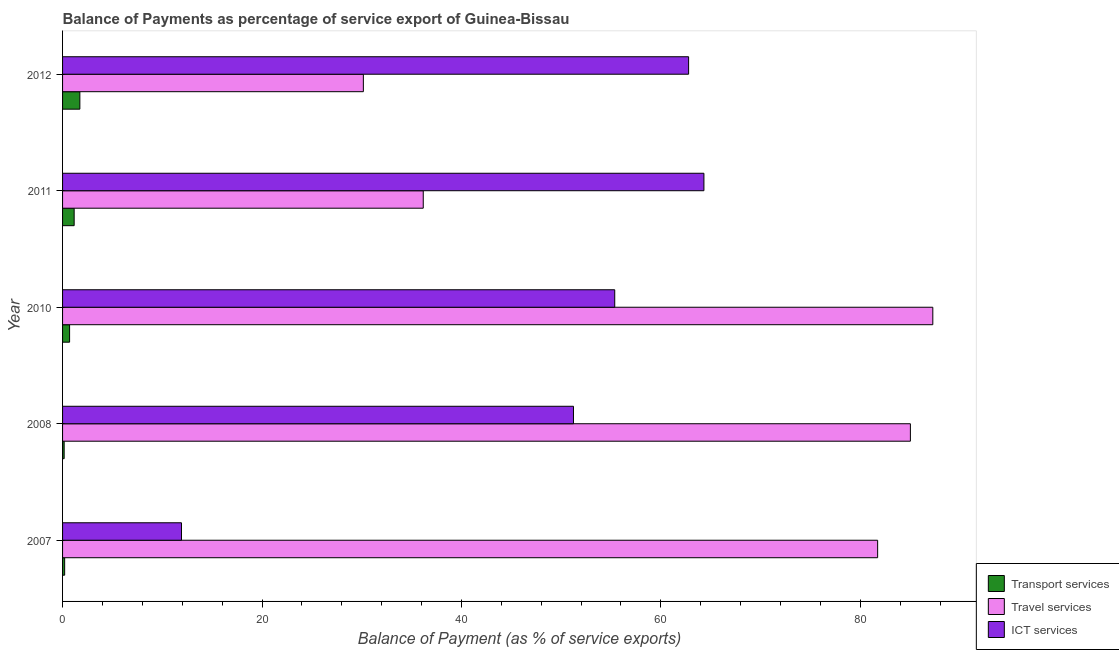How many different coloured bars are there?
Give a very brief answer. 3. How many groups of bars are there?
Offer a terse response. 5. Are the number of bars per tick equal to the number of legend labels?
Offer a very short reply. Yes. How many bars are there on the 5th tick from the bottom?
Your response must be concise. 3. What is the label of the 1st group of bars from the top?
Your answer should be compact. 2012. What is the balance of payment of travel services in 2010?
Your answer should be compact. 87.27. Across all years, what is the maximum balance of payment of ict services?
Provide a short and direct response. 64.32. Across all years, what is the minimum balance of payment of transport services?
Your response must be concise. 0.16. In which year was the balance of payment of travel services maximum?
Ensure brevity in your answer.  2010. What is the total balance of payment of ict services in the graph?
Provide a succinct answer. 245.65. What is the difference between the balance of payment of travel services in 2008 and that in 2012?
Make the answer very short. 54.86. What is the difference between the balance of payment of travel services in 2012 and the balance of payment of transport services in 2011?
Make the answer very short. 29. What is the average balance of payment of transport services per year?
Your answer should be very brief. 0.79. In the year 2012, what is the difference between the balance of payment of travel services and balance of payment of transport services?
Your answer should be compact. 28.43. What is the ratio of the balance of payment of travel services in 2007 to that in 2008?
Your response must be concise. 0.96. Is the balance of payment of travel services in 2007 less than that in 2012?
Make the answer very short. No. Is the difference between the balance of payment of transport services in 2007 and 2012 greater than the difference between the balance of payment of ict services in 2007 and 2012?
Offer a terse response. Yes. What is the difference between the highest and the second highest balance of payment of ict services?
Offer a terse response. 1.53. What is the difference between the highest and the lowest balance of payment of ict services?
Offer a very short reply. 52.39. What does the 2nd bar from the top in 2012 represents?
Ensure brevity in your answer.  Travel services. What does the 2nd bar from the bottom in 2012 represents?
Your answer should be very brief. Travel services. How many bars are there?
Keep it short and to the point. 15. Are all the bars in the graph horizontal?
Keep it short and to the point. Yes. How many years are there in the graph?
Provide a short and direct response. 5. Does the graph contain grids?
Provide a short and direct response. No. How many legend labels are there?
Your answer should be very brief. 3. What is the title of the graph?
Provide a short and direct response. Balance of Payments as percentage of service export of Guinea-Bissau. What is the label or title of the X-axis?
Provide a short and direct response. Balance of Payment (as % of service exports). What is the Balance of Payment (as % of service exports) in Transport services in 2007?
Your response must be concise. 0.21. What is the Balance of Payment (as % of service exports) of Travel services in 2007?
Keep it short and to the point. 81.74. What is the Balance of Payment (as % of service exports) in ICT services in 2007?
Provide a short and direct response. 11.93. What is the Balance of Payment (as % of service exports) of Transport services in 2008?
Provide a short and direct response. 0.16. What is the Balance of Payment (as % of service exports) in Travel services in 2008?
Make the answer very short. 85.03. What is the Balance of Payment (as % of service exports) in ICT services in 2008?
Keep it short and to the point. 51.24. What is the Balance of Payment (as % of service exports) in Transport services in 2010?
Keep it short and to the point. 0.7. What is the Balance of Payment (as % of service exports) of Travel services in 2010?
Offer a terse response. 87.27. What is the Balance of Payment (as % of service exports) of ICT services in 2010?
Your answer should be compact. 55.38. What is the Balance of Payment (as % of service exports) in Transport services in 2011?
Keep it short and to the point. 1.16. What is the Balance of Payment (as % of service exports) in Travel services in 2011?
Your response must be concise. 36.17. What is the Balance of Payment (as % of service exports) of ICT services in 2011?
Your response must be concise. 64.32. What is the Balance of Payment (as % of service exports) of Transport services in 2012?
Offer a terse response. 1.73. What is the Balance of Payment (as % of service exports) in Travel services in 2012?
Offer a terse response. 30.17. What is the Balance of Payment (as % of service exports) of ICT services in 2012?
Provide a short and direct response. 62.79. Across all years, what is the maximum Balance of Payment (as % of service exports) in Transport services?
Your response must be concise. 1.73. Across all years, what is the maximum Balance of Payment (as % of service exports) of Travel services?
Offer a terse response. 87.27. Across all years, what is the maximum Balance of Payment (as % of service exports) in ICT services?
Keep it short and to the point. 64.32. Across all years, what is the minimum Balance of Payment (as % of service exports) in Transport services?
Your answer should be compact. 0.16. Across all years, what is the minimum Balance of Payment (as % of service exports) in Travel services?
Offer a terse response. 30.17. Across all years, what is the minimum Balance of Payment (as % of service exports) of ICT services?
Keep it short and to the point. 11.93. What is the total Balance of Payment (as % of service exports) in Transport services in the graph?
Make the answer very short. 3.97. What is the total Balance of Payment (as % of service exports) of Travel services in the graph?
Your answer should be compact. 320.38. What is the total Balance of Payment (as % of service exports) in ICT services in the graph?
Offer a very short reply. 245.65. What is the difference between the Balance of Payment (as % of service exports) of Transport services in 2007 and that in 2008?
Ensure brevity in your answer.  0.05. What is the difference between the Balance of Payment (as % of service exports) of Travel services in 2007 and that in 2008?
Provide a succinct answer. -3.28. What is the difference between the Balance of Payment (as % of service exports) of ICT services in 2007 and that in 2008?
Your answer should be compact. -39.31. What is the difference between the Balance of Payment (as % of service exports) in Transport services in 2007 and that in 2010?
Ensure brevity in your answer.  -0.5. What is the difference between the Balance of Payment (as % of service exports) in Travel services in 2007 and that in 2010?
Provide a short and direct response. -5.53. What is the difference between the Balance of Payment (as % of service exports) in ICT services in 2007 and that in 2010?
Give a very brief answer. -43.45. What is the difference between the Balance of Payment (as % of service exports) of Transport services in 2007 and that in 2011?
Provide a succinct answer. -0.95. What is the difference between the Balance of Payment (as % of service exports) of Travel services in 2007 and that in 2011?
Give a very brief answer. 45.57. What is the difference between the Balance of Payment (as % of service exports) in ICT services in 2007 and that in 2011?
Offer a terse response. -52.39. What is the difference between the Balance of Payment (as % of service exports) of Transport services in 2007 and that in 2012?
Your response must be concise. -1.52. What is the difference between the Balance of Payment (as % of service exports) of Travel services in 2007 and that in 2012?
Make the answer very short. 51.58. What is the difference between the Balance of Payment (as % of service exports) of ICT services in 2007 and that in 2012?
Make the answer very short. -50.86. What is the difference between the Balance of Payment (as % of service exports) in Transport services in 2008 and that in 2010?
Provide a short and direct response. -0.54. What is the difference between the Balance of Payment (as % of service exports) of Travel services in 2008 and that in 2010?
Your answer should be compact. -2.25. What is the difference between the Balance of Payment (as % of service exports) in ICT services in 2008 and that in 2010?
Your response must be concise. -4.14. What is the difference between the Balance of Payment (as % of service exports) of Transport services in 2008 and that in 2011?
Ensure brevity in your answer.  -1. What is the difference between the Balance of Payment (as % of service exports) in Travel services in 2008 and that in 2011?
Provide a short and direct response. 48.85. What is the difference between the Balance of Payment (as % of service exports) in ICT services in 2008 and that in 2011?
Make the answer very short. -13.08. What is the difference between the Balance of Payment (as % of service exports) in Transport services in 2008 and that in 2012?
Give a very brief answer. -1.57. What is the difference between the Balance of Payment (as % of service exports) in Travel services in 2008 and that in 2012?
Your answer should be very brief. 54.86. What is the difference between the Balance of Payment (as % of service exports) in ICT services in 2008 and that in 2012?
Make the answer very short. -11.55. What is the difference between the Balance of Payment (as % of service exports) in Transport services in 2010 and that in 2011?
Your answer should be compact. -0.46. What is the difference between the Balance of Payment (as % of service exports) of Travel services in 2010 and that in 2011?
Your answer should be compact. 51.1. What is the difference between the Balance of Payment (as % of service exports) of ICT services in 2010 and that in 2011?
Your answer should be compact. -8.94. What is the difference between the Balance of Payment (as % of service exports) in Transport services in 2010 and that in 2012?
Keep it short and to the point. -1.03. What is the difference between the Balance of Payment (as % of service exports) of Travel services in 2010 and that in 2012?
Your answer should be very brief. 57.11. What is the difference between the Balance of Payment (as % of service exports) in ICT services in 2010 and that in 2012?
Your response must be concise. -7.41. What is the difference between the Balance of Payment (as % of service exports) of Transport services in 2011 and that in 2012?
Ensure brevity in your answer.  -0.57. What is the difference between the Balance of Payment (as % of service exports) of Travel services in 2011 and that in 2012?
Make the answer very short. 6.01. What is the difference between the Balance of Payment (as % of service exports) of ICT services in 2011 and that in 2012?
Your response must be concise. 1.53. What is the difference between the Balance of Payment (as % of service exports) of Transport services in 2007 and the Balance of Payment (as % of service exports) of Travel services in 2008?
Offer a very short reply. -84.82. What is the difference between the Balance of Payment (as % of service exports) of Transport services in 2007 and the Balance of Payment (as % of service exports) of ICT services in 2008?
Offer a terse response. -51.03. What is the difference between the Balance of Payment (as % of service exports) in Travel services in 2007 and the Balance of Payment (as % of service exports) in ICT services in 2008?
Keep it short and to the point. 30.5. What is the difference between the Balance of Payment (as % of service exports) of Transport services in 2007 and the Balance of Payment (as % of service exports) of Travel services in 2010?
Offer a very short reply. -87.06. What is the difference between the Balance of Payment (as % of service exports) in Transport services in 2007 and the Balance of Payment (as % of service exports) in ICT services in 2010?
Your answer should be compact. -55.17. What is the difference between the Balance of Payment (as % of service exports) of Travel services in 2007 and the Balance of Payment (as % of service exports) of ICT services in 2010?
Keep it short and to the point. 26.37. What is the difference between the Balance of Payment (as % of service exports) of Transport services in 2007 and the Balance of Payment (as % of service exports) of Travel services in 2011?
Your response must be concise. -35.96. What is the difference between the Balance of Payment (as % of service exports) in Transport services in 2007 and the Balance of Payment (as % of service exports) in ICT services in 2011?
Provide a short and direct response. -64.11. What is the difference between the Balance of Payment (as % of service exports) in Travel services in 2007 and the Balance of Payment (as % of service exports) in ICT services in 2011?
Provide a short and direct response. 17.42. What is the difference between the Balance of Payment (as % of service exports) in Transport services in 2007 and the Balance of Payment (as % of service exports) in Travel services in 2012?
Keep it short and to the point. -29.96. What is the difference between the Balance of Payment (as % of service exports) of Transport services in 2007 and the Balance of Payment (as % of service exports) of ICT services in 2012?
Your answer should be very brief. -62.58. What is the difference between the Balance of Payment (as % of service exports) of Travel services in 2007 and the Balance of Payment (as % of service exports) of ICT services in 2012?
Make the answer very short. 18.96. What is the difference between the Balance of Payment (as % of service exports) of Transport services in 2008 and the Balance of Payment (as % of service exports) of Travel services in 2010?
Your answer should be compact. -87.11. What is the difference between the Balance of Payment (as % of service exports) of Transport services in 2008 and the Balance of Payment (as % of service exports) of ICT services in 2010?
Give a very brief answer. -55.22. What is the difference between the Balance of Payment (as % of service exports) in Travel services in 2008 and the Balance of Payment (as % of service exports) in ICT services in 2010?
Your answer should be very brief. 29.65. What is the difference between the Balance of Payment (as % of service exports) of Transport services in 2008 and the Balance of Payment (as % of service exports) of Travel services in 2011?
Give a very brief answer. -36.01. What is the difference between the Balance of Payment (as % of service exports) in Transport services in 2008 and the Balance of Payment (as % of service exports) in ICT services in 2011?
Keep it short and to the point. -64.16. What is the difference between the Balance of Payment (as % of service exports) of Travel services in 2008 and the Balance of Payment (as % of service exports) of ICT services in 2011?
Provide a short and direct response. 20.71. What is the difference between the Balance of Payment (as % of service exports) in Transport services in 2008 and the Balance of Payment (as % of service exports) in Travel services in 2012?
Provide a short and direct response. -30.01. What is the difference between the Balance of Payment (as % of service exports) of Transport services in 2008 and the Balance of Payment (as % of service exports) of ICT services in 2012?
Make the answer very short. -62.63. What is the difference between the Balance of Payment (as % of service exports) in Travel services in 2008 and the Balance of Payment (as % of service exports) in ICT services in 2012?
Make the answer very short. 22.24. What is the difference between the Balance of Payment (as % of service exports) of Transport services in 2010 and the Balance of Payment (as % of service exports) of Travel services in 2011?
Your answer should be compact. -35.47. What is the difference between the Balance of Payment (as % of service exports) of Transport services in 2010 and the Balance of Payment (as % of service exports) of ICT services in 2011?
Give a very brief answer. -63.62. What is the difference between the Balance of Payment (as % of service exports) in Travel services in 2010 and the Balance of Payment (as % of service exports) in ICT services in 2011?
Keep it short and to the point. 22.95. What is the difference between the Balance of Payment (as % of service exports) in Transport services in 2010 and the Balance of Payment (as % of service exports) in Travel services in 2012?
Ensure brevity in your answer.  -29.46. What is the difference between the Balance of Payment (as % of service exports) of Transport services in 2010 and the Balance of Payment (as % of service exports) of ICT services in 2012?
Make the answer very short. -62.08. What is the difference between the Balance of Payment (as % of service exports) of Travel services in 2010 and the Balance of Payment (as % of service exports) of ICT services in 2012?
Your response must be concise. 24.49. What is the difference between the Balance of Payment (as % of service exports) in Transport services in 2011 and the Balance of Payment (as % of service exports) in Travel services in 2012?
Your response must be concise. -29. What is the difference between the Balance of Payment (as % of service exports) in Transport services in 2011 and the Balance of Payment (as % of service exports) in ICT services in 2012?
Give a very brief answer. -61.62. What is the difference between the Balance of Payment (as % of service exports) in Travel services in 2011 and the Balance of Payment (as % of service exports) in ICT services in 2012?
Offer a terse response. -26.61. What is the average Balance of Payment (as % of service exports) in Transport services per year?
Provide a short and direct response. 0.79. What is the average Balance of Payment (as % of service exports) in Travel services per year?
Give a very brief answer. 64.08. What is the average Balance of Payment (as % of service exports) in ICT services per year?
Give a very brief answer. 49.13. In the year 2007, what is the difference between the Balance of Payment (as % of service exports) in Transport services and Balance of Payment (as % of service exports) in Travel services?
Give a very brief answer. -81.53. In the year 2007, what is the difference between the Balance of Payment (as % of service exports) of Transport services and Balance of Payment (as % of service exports) of ICT services?
Make the answer very short. -11.72. In the year 2007, what is the difference between the Balance of Payment (as % of service exports) of Travel services and Balance of Payment (as % of service exports) of ICT services?
Your answer should be compact. 69.82. In the year 2008, what is the difference between the Balance of Payment (as % of service exports) in Transport services and Balance of Payment (as % of service exports) in Travel services?
Offer a terse response. -84.87. In the year 2008, what is the difference between the Balance of Payment (as % of service exports) in Transport services and Balance of Payment (as % of service exports) in ICT services?
Keep it short and to the point. -51.08. In the year 2008, what is the difference between the Balance of Payment (as % of service exports) of Travel services and Balance of Payment (as % of service exports) of ICT services?
Provide a short and direct response. 33.79. In the year 2010, what is the difference between the Balance of Payment (as % of service exports) of Transport services and Balance of Payment (as % of service exports) of Travel services?
Keep it short and to the point. -86.57. In the year 2010, what is the difference between the Balance of Payment (as % of service exports) in Transport services and Balance of Payment (as % of service exports) in ICT services?
Keep it short and to the point. -54.67. In the year 2010, what is the difference between the Balance of Payment (as % of service exports) in Travel services and Balance of Payment (as % of service exports) in ICT services?
Provide a short and direct response. 31.9. In the year 2011, what is the difference between the Balance of Payment (as % of service exports) of Transport services and Balance of Payment (as % of service exports) of Travel services?
Offer a terse response. -35.01. In the year 2011, what is the difference between the Balance of Payment (as % of service exports) in Transport services and Balance of Payment (as % of service exports) in ICT services?
Make the answer very short. -63.16. In the year 2011, what is the difference between the Balance of Payment (as % of service exports) in Travel services and Balance of Payment (as % of service exports) in ICT services?
Provide a short and direct response. -28.15. In the year 2012, what is the difference between the Balance of Payment (as % of service exports) of Transport services and Balance of Payment (as % of service exports) of Travel services?
Your answer should be very brief. -28.43. In the year 2012, what is the difference between the Balance of Payment (as % of service exports) in Transport services and Balance of Payment (as % of service exports) in ICT services?
Give a very brief answer. -61.05. In the year 2012, what is the difference between the Balance of Payment (as % of service exports) in Travel services and Balance of Payment (as % of service exports) in ICT services?
Offer a terse response. -32.62. What is the ratio of the Balance of Payment (as % of service exports) of Transport services in 2007 to that in 2008?
Your answer should be compact. 1.31. What is the ratio of the Balance of Payment (as % of service exports) of Travel services in 2007 to that in 2008?
Offer a very short reply. 0.96. What is the ratio of the Balance of Payment (as % of service exports) in ICT services in 2007 to that in 2008?
Keep it short and to the point. 0.23. What is the ratio of the Balance of Payment (as % of service exports) in Transport services in 2007 to that in 2010?
Your answer should be compact. 0.3. What is the ratio of the Balance of Payment (as % of service exports) in Travel services in 2007 to that in 2010?
Provide a succinct answer. 0.94. What is the ratio of the Balance of Payment (as % of service exports) in ICT services in 2007 to that in 2010?
Your answer should be very brief. 0.22. What is the ratio of the Balance of Payment (as % of service exports) in Transport services in 2007 to that in 2011?
Give a very brief answer. 0.18. What is the ratio of the Balance of Payment (as % of service exports) in Travel services in 2007 to that in 2011?
Ensure brevity in your answer.  2.26. What is the ratio of the Balance of Payment (as % of service exports) in ICT services in 2007 to that in 2011?
Provide a short and direct response. 0.19. What is the ratio of the Balance of Payment (as % of service exports) in Transport services in 2007 to that in 2012?
Your answer should be compact. 0.12. What is the ratio of the Balance of Payment (as % of service exports) in Travel services in 2007 to that in 2012?
Your answer should be compact. 2.71. What is the ratio of the Balance of Payment (as % of service exports) in ICT services in 2007 to that in 2012?
Provide a short and direct response. 0.19. What is the ratio of the Balance of Payment (as % of service exports) in Transport services in 2008 to that in 2010?
Give a very brief answer. 0.23. What is the ratio of the Balance of Payment (as % of service exports) of Travel services in 2008 to that in 2010?
Make the answer very short. 0.97. What is the ratio of the Balance of Payment (as % of service exports) of ICT services in 2008 to that in 2010?
Give a very brief answer. 0.93. What is the ratio of the Balance of Payment (as % of service exports) of Transport services in 2008 to that in 2011?
Offer a very short reply. 0.14. What is the ratio of the Balance of Payment (as % of service exports) of Travel services in 2008 to that in 2011?
Give a very brief answer. 2.35. What is the ratio of the Balance of Payment (as % of service exports) in ICT services in 2008 to that in 2011?
Offer a terse response. 0.8. What is the ratio of the Balance of Payment (as % of service exports) in Transport services in 2008 to that in 2012?
Make the answer very short. 0.09. What is the ratio of the Balance of Payment (as % of service exports) in Travel services in 2008 to that in 2012?
Provide a succinct answer. 2.82. What is the ratio of the Balance of Payment (as % of service exports) of ICT services in 2008 to that in 2012?
Give a very brief answer. 0.82. What is the ratio of the Balance of Payment (as % of service exports) in Transport services in 2010 to that in 2011?
Offer a very short reply. 0.61. What is the ratio of the Balance of Payment (as % of service exports) of Travel services in 2010 to that in 2011?
Ensure brevity in your answer.  2.41. What is the ratio of the Balance of Payment (as % of service exports) in ICT services in 2010 to that in 2011?
Give a very brief answer. 0.86. What is the ratio of the Balance of Payment (as % of service exports) in Transport services in 2010 to that in 2012?
Offer a very short reply. 0.41. What is the ratio of the Balance of Payment (as % of service exports) of Travel services in 2010 to that in 2012?
Offer a very short reply. 2.89. What is the ratio of the Balance of Payment (as % of service exports) of ICT services in 2010 to that in 2012?
Provide a succinct answer. 0.88. What is the ratio of the Balance of Payment (as % of service exports) of Transport services in 2011 to that in 2012?
Your answer should be compact. 0.67. What is the ratio of the Balance of Payment (as % of service exports) in Travel services in 2011 to that in 2012?
Ensure brevity in your answer.  1.2. What is the ratio of the Balance of Payment (as % of service exports) of ICT services in 2011 to that in 2012?
Offer a very short reply. 1.02. What is the difference between the highest and the second highest Balance of Payment (as % of service exports) in Transport services?
Your response must be concise. 0.57. What is the difference between the highest and the second highest Balance of Payment (as % of service exports) of Travel services?
Give a very brief answer. 2.25. What is the difference between the highest and the second highest Balance of Payment (as % of service exports) in ICT services?
Your response must be concise. 1.53. What is the difference between the highest and the lowest Balance of Payment (as % of service exports) in Transport services?
Your answer should be very brief. 1.57. What is the difference between the highest and the lowest Balance of Payment (as % of service exports) of Travel services?
Your response must be concise. 57.11. What is the difference between the highest and the lowest Balance of Payment (as % of service exports) in ICT services?
Provide a short and direct response. 52.39. 